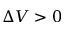<formula> <loc_0><loc_0><loc_500><loc_500>\Delta V > 0</formula> 